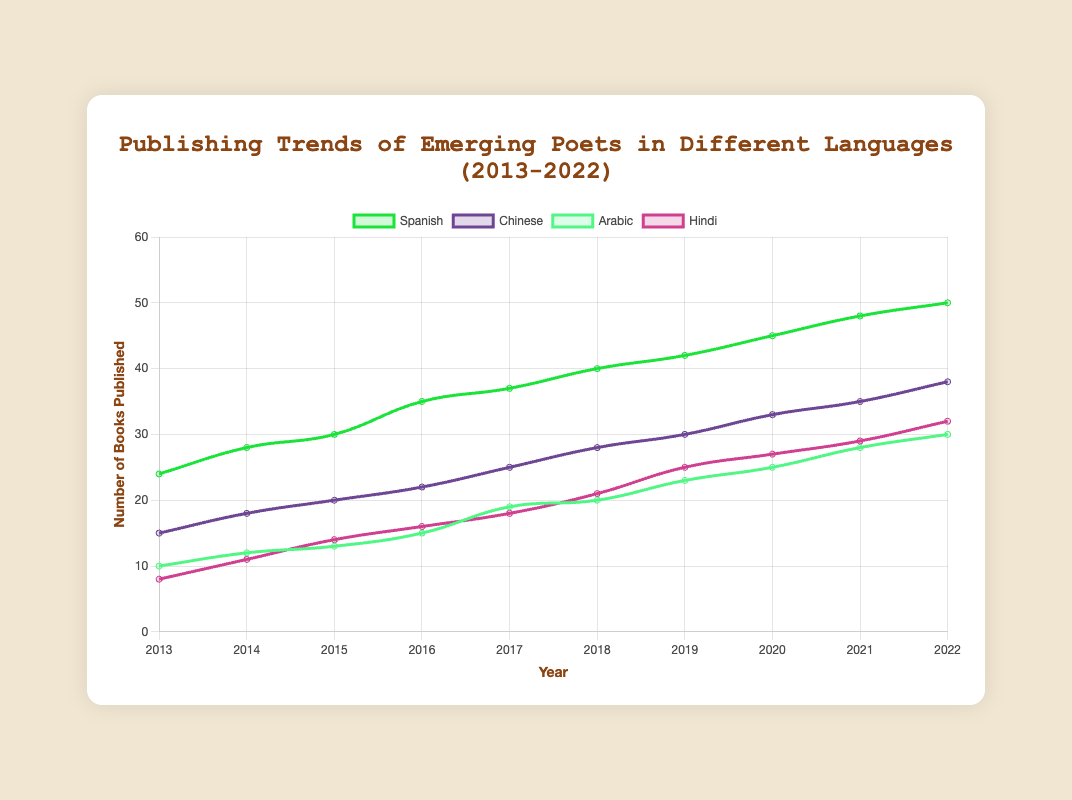How many more books were published in Spanish compared to Chinese in 2022? To find the difference, subtract the number of books published in Chinese from the number published in Spanish for 2022. Spanish books: 50, Chinese books: 38. Difference: 50 - 38 = 12
Answer: 12 Which year had the highest number of books published in Hindi? By checking the number of Hindi books published each year, find the highest value. The highest number of Hindi books published is 32 in 2022.
Answer: 2022 Which language saw the most consistent increase in the number of published books over the decade? To determine consistency, observe the trends for each language. Spanish consistently increased every year without any drop.
Answer: Spanish In 2015, which language had the second-highest number of published books? First, list the number of books for each language in 2015: Spanish (30), Chinese (20), Arabic (13), Hindi (14). The second-highest is Chinese with 20 books.
Answer: Chinese Between which consecutive years did Arabic literature see the highest increase in published books? Calculate the difference in the number of books published each year, then find the maximum increase. The highest increase is from 2016 (15) to 2017 (19), an increase of 4 books.
Answer: 2016-2017 What is the average number of books published annually in Chinese from 2016 to 2020? Sum the number of Chinese books published between 2016 and 2020 and divide by the number of years. Sum: 22+25+28+30+33 = 138. Average: 138/5 = 27.6
Answer: 27.6 Compare the number of books published in Arabic and Hindi in 2020. Which was higher? Check the numbers for 2020: Arabic (25), Hindi (27). Hindi had more books published.
Answer: Hindi Which year did Chinese poets see the largest increase in their published works compared to the previous year? Compare annual increments: 2014-2015 (3), 2015-2016 (2), 2016-2017 (3), 2017-2018 (3), 2018-2019 (2), 2019-2020 (3), 2020-2021 (2), 2021-2022 (3). The largest increases (3) are in 2014-2015, 2016-2017, 2017-2018, 2019-2020, and 2021-2022, showing equal largest increases.
Answer: 2014-2015, 2016-2017, 2017-2018, 2019-2020, 2021-2022 How many books were published in Arabic and Spanish combined in 2021? Sum the number of books published in Arabic and Spanish in 2021. Arabic: 28, Spanish: 48. Total: 28 + 48 = 76
Answer: 76 